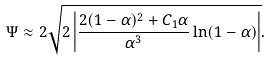<formula> <loc_0><loc_0><loc_500><loc_500>\Psi \approx 2 \sqrt { 2 \left | \frac { 2 ( 1 - \alpha ) ^ { 2 } + C _ { 1 } \alpha } { \alpha ^ { 3 } } \ln ( 1 - \alpha ) \right | } .</formula> 